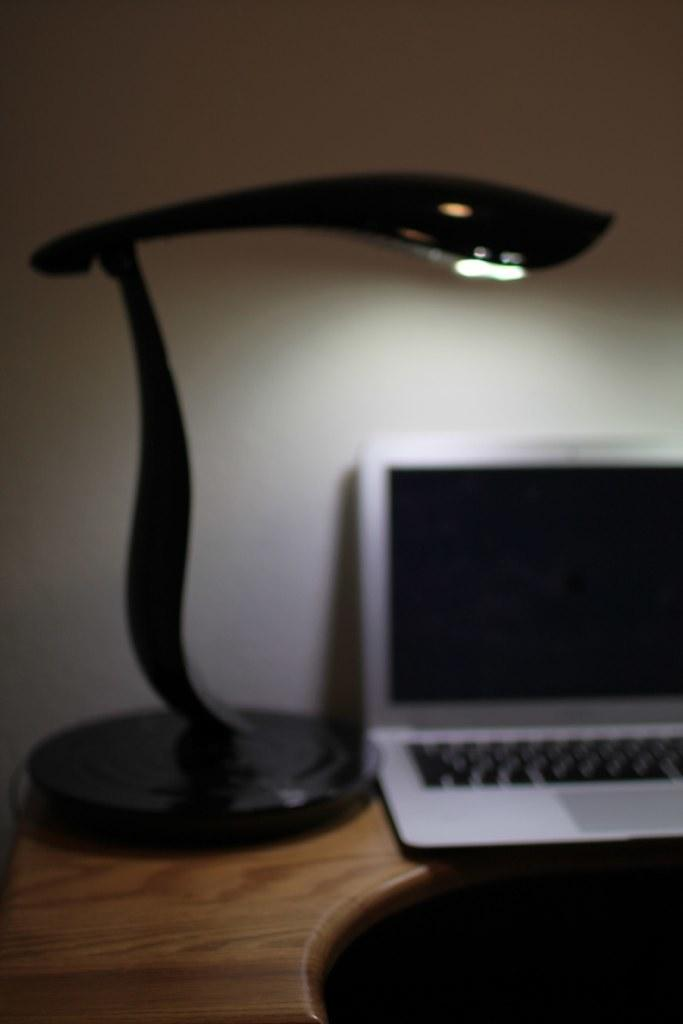Where was the image taken? The image was taken in a room. What furniture is present in the room? There is a wooden table in the room. What is on the table in the image? There is a light and a laptop on the table. What can be seen on the laptop's background? The background of the laptop is a white wall. How many people are visible in the image? There are no people visible in the image; it only shows a wooden table, a light, a laptop, and a white wall. What type of trees can be seen through the window in the image? There is no window or trees present in the image. 